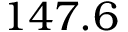<formula> <loc_0><loc_0><loc_500><loc_500>1 4 7 . 6</formula> 